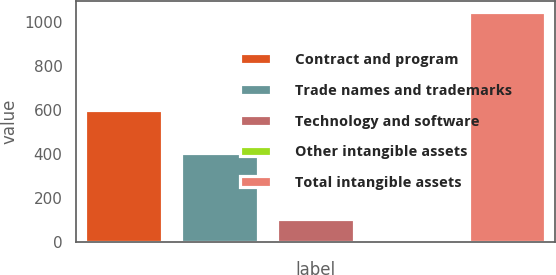Convert chart. <chart><loc_0><loc_0><loc_500><loc_500><bar_chart><fcel>Contract and program<fcel>Trade names and trademarks<fcel>Technology and software<fcel>Other intangible assets<fcel>Total intangible assets<nl><fcel>601<fcel>404<fcel>105.3<fcel>1<fcel>1044<nl></chart> 